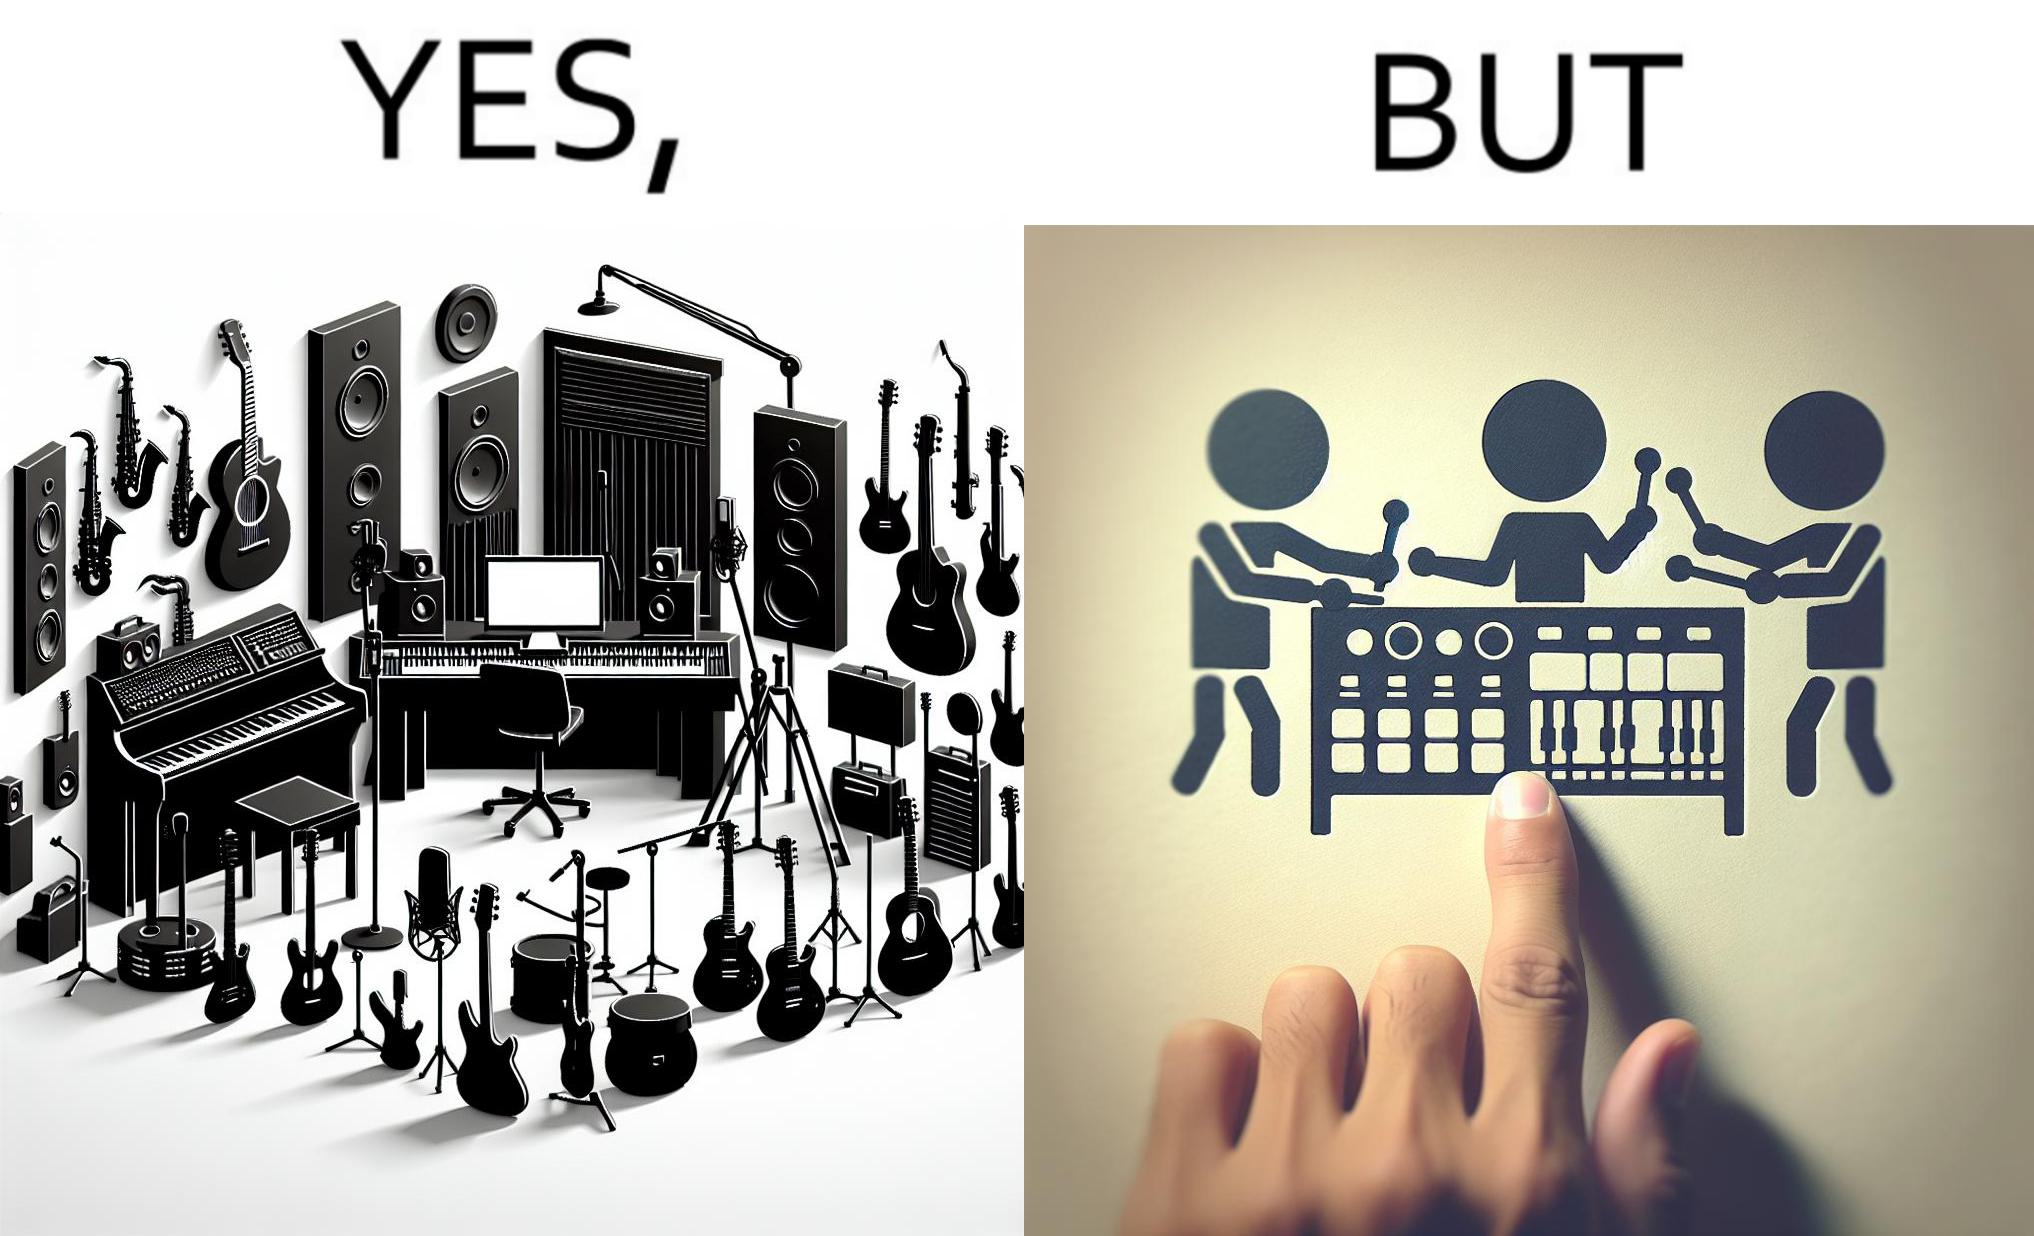Would you classify this image as satirical? Yes, this image is satirical. 